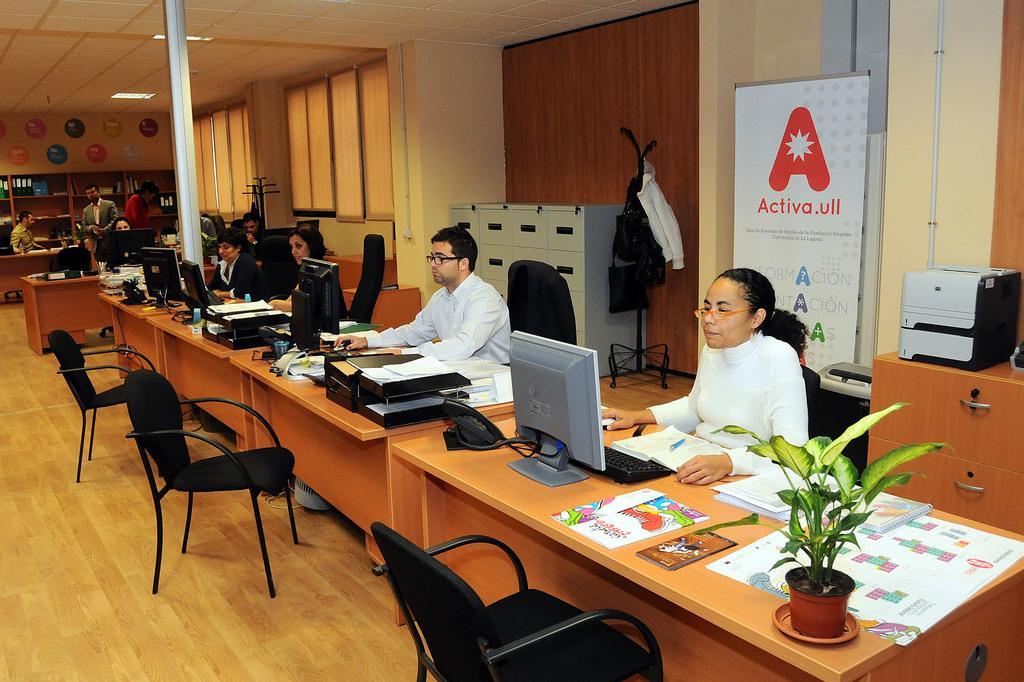How would you summarize this image in a sentence or two? In this picture we can see few persons sitting on chairs infront of atbale and on the table we can see monitors, keyboards, printers, papers, house plant. These are empty chairs. This is a locker. Here we can see a flexi. here we can see few persons standing. This is a floor. 